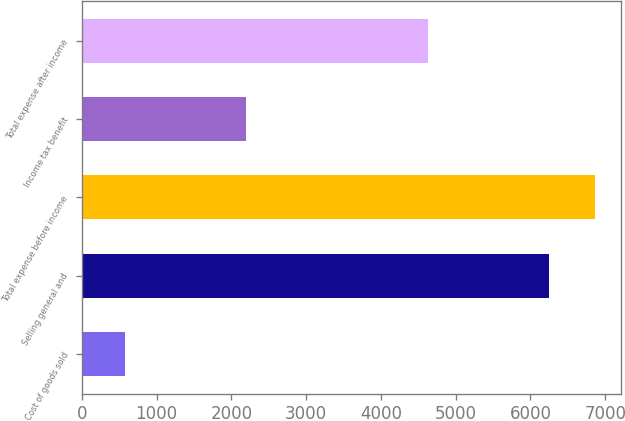<chart> <loc_0><loc_0><loc_500><loc_500><bar_chart><fcel>Cost of goods sold<fcel>Selling general and<fcel>Total expense before income<fcel>Income tax benefit<fcel>Total expense after income<nl><fcel>581<fcel>6245<fcel>6869.5<fcel>2194<fcel>4632<nl></chart> 